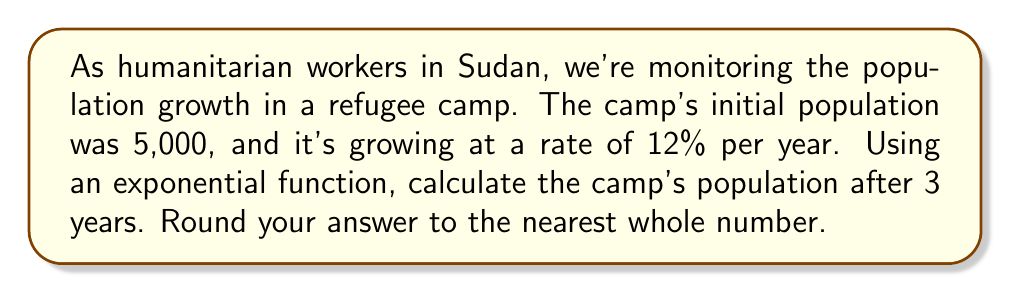Can you solve this math problem? Let's approach this step-by-step using the exponential growth formula:

1) The exponential growth formula is:
   $$P(t) = P_0 \cdot (1 + r)^t$$
   Where:
   $P(t)$ is the population at time $t$
   $P_0$ is the initial population
   $r$ is the growth rate (as a decimal)
   $t$ is the time in years

2) We know:
   $P_0 = 5,000$
   $r = 12\% = 0.12$
   $t = 3$ years

3) Let's substitute these values into our formula:
   $$P(3) = 5,000 \cdot (1 + 0.12)^3$$

4) Simplify inside the parentheses:
   $$P(3) = 5,000 \cdot (1.12)^3$$

5) Calculate $(1.12)^3$:
   $$P(3) = 5,000 \cdot 1.404928$$

6) Multiply:
   $$P(3) = 7,024.64$$

7) Rounding to the nearest whole number:
   $$P(3) \approx 7,025$$
Answer: 7,025 refugees 